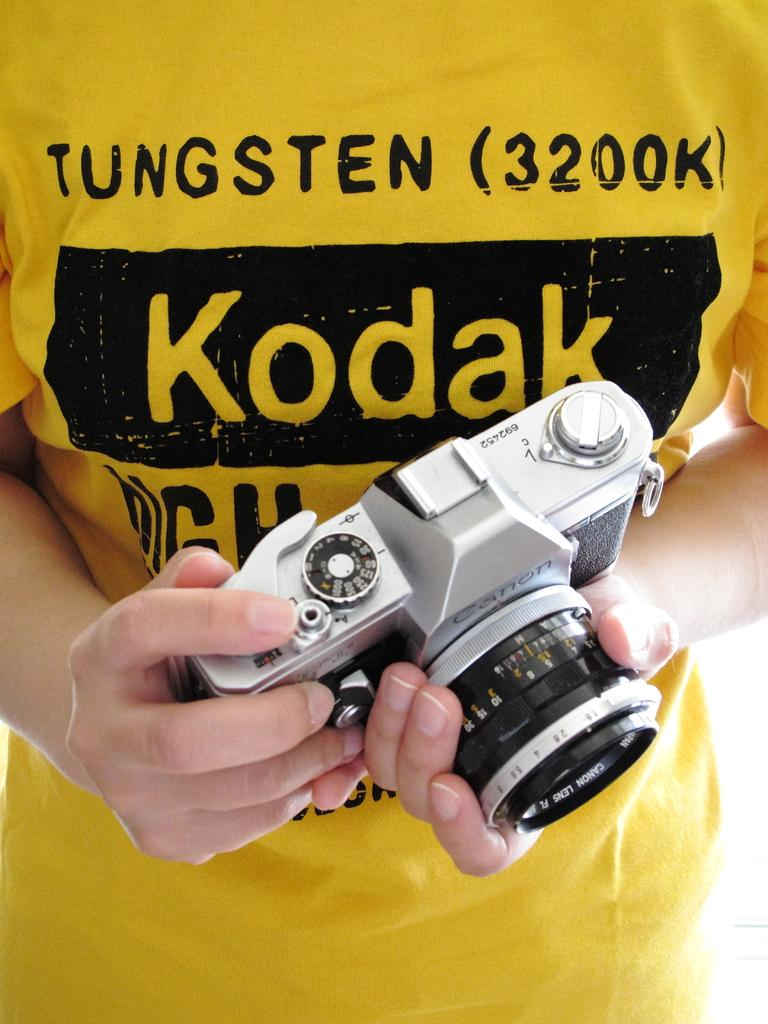What object is being held by a person in the image? There is a camera in the image, and it is being held by a person. How does the person in the image use a comb to capture a kiss in the image? There is no comb or kiss present in the image; it only features a person holding a camera. 